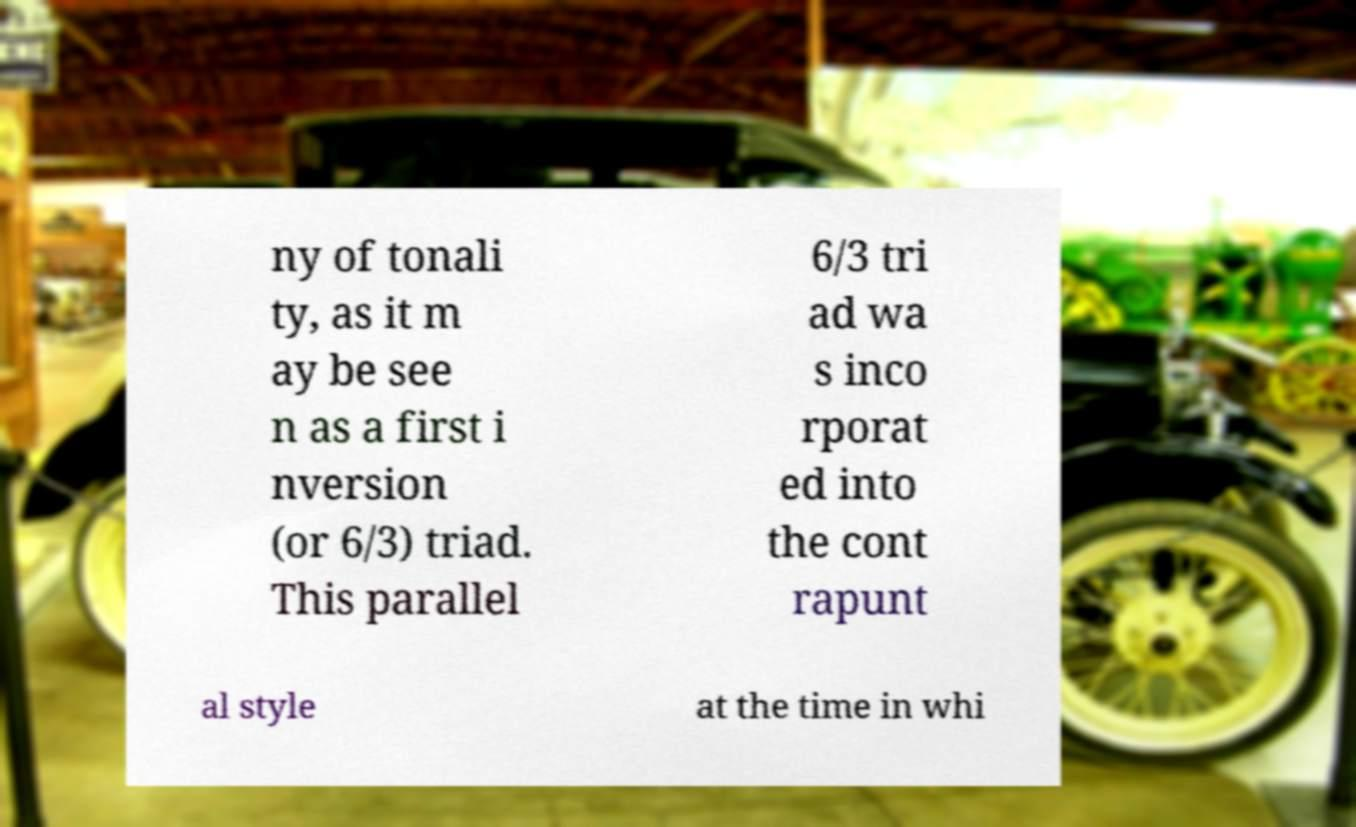Can you read and provide the text displayed in the image?This photo seems to have some interesting text. Can you extract and type it out for me? ny of tonali ty, as it m ay be see n as a first i nversion (or 6/3) triad. This parallel 6/3 tri ad wa s inco rporat ed into the cont rapunt al style at the time in whi 